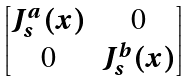<formula> <loc_0><loc_0><loc_500><loc_500>\begin{bmatrix} J ^ { a } _ { s } ( x ) & 0 \\ 0 & J ^ { b } _ { s } ( x ) \end{bmatrix}</formula> 